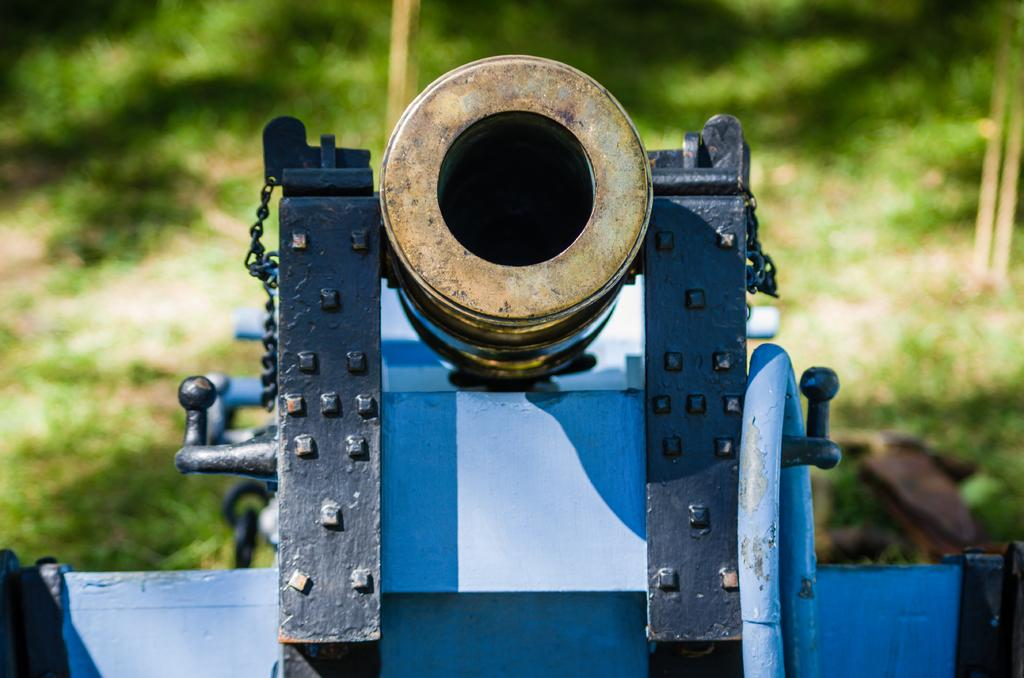What is the main subject in the center of the image? There is a cannon in the center of the image. What can be seen in the background of the image? There are trees in the background of the image. What type of sack is being used to control the cannon in the image? There is no sack or control mechanism for the cannon visible in the image. What color are the trousers of the person operating the cannon in the image? There is no person operating the cannon in the image, and therefore no trousers to describe. 